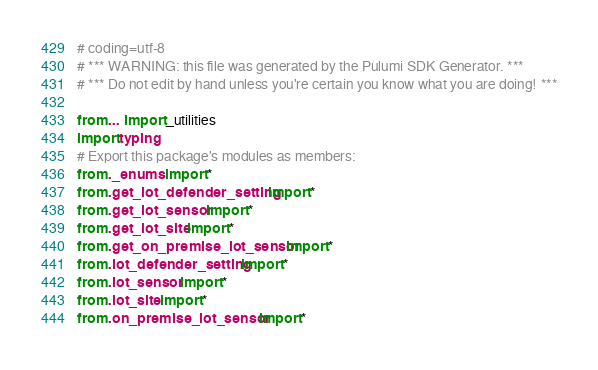<code> <loc_0><loc_0><loc_500><loc_500><_Python_># coding=utf-8
# *** WARNING: this file was generated by the Pulumi SDK Generator. ***
# *** Do not edit by hand unless you're certain you know what you are doing! ***

from ... import _utilities
import typing
# Export this package's modules as members:
from ._enums import *
from .get_iot_defender_setting import *
from .get_iot_sensor import *
from .get_iot_site import *
from .get_on_premise_iot_sensor import *
from .iot_defender_setting import *
from .iot_sensor import *
from .iot_site import *
from .on_premise_iot_sensor import *
</code> 